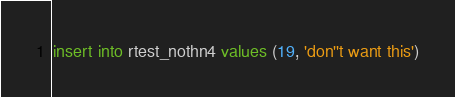Convert code to text. <code><loc_0><loc_0><loc_500><loc_500><_SQL_>insert into rtest_nothn4 values (19, 'don''t want this')
</code> 